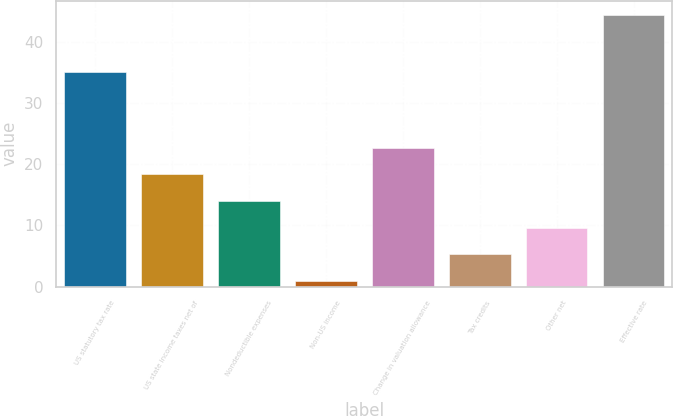<chart> <loc_0><loc_0><loc_500><loc_500><bar_chart><fcel>US statutory tax rate<fcel>US state income taxes net of<fcel>Nondeductible expenses<fcel>Non-US income<fcel>Change in valuation allowance<fcel>Tax credits<fcel>Other net<fcel>Effective rate<nl><fcel>35<fcel>18.3<fcel>13.95<fcel>0.9<fcel>22.65<fcel>5.25<fcel>9.6<fcel>44.4<nl></chart> 